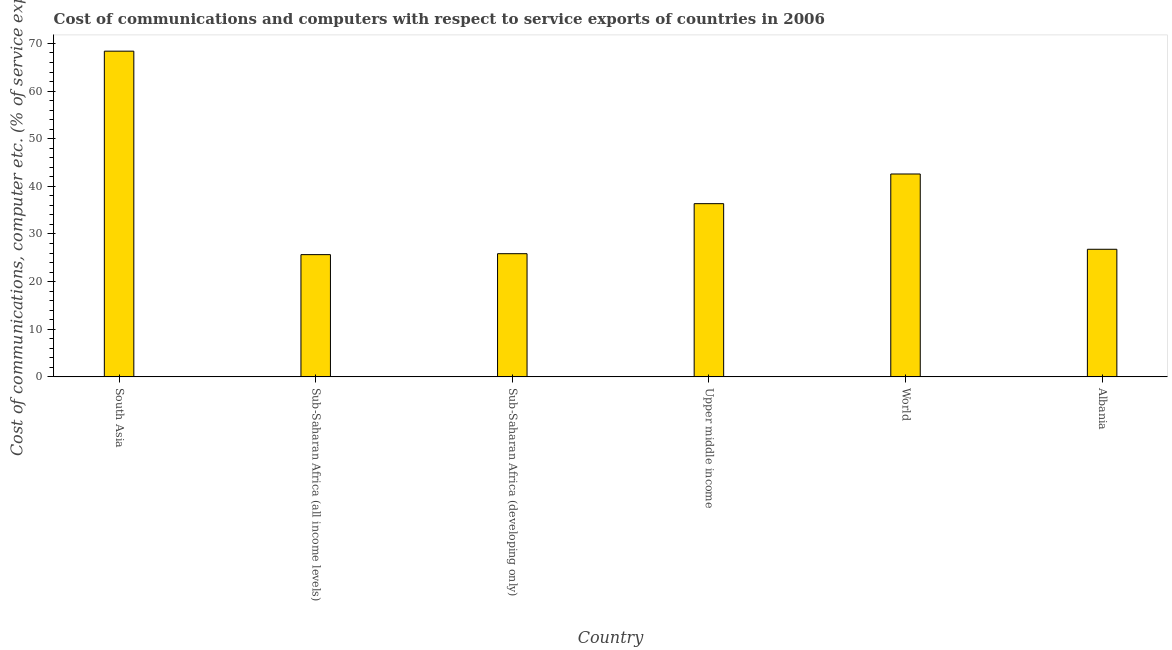Does the graph contain any zero values?
Ensure brevity in your answer.  No. What is the title of the graph?
Make the answer very short. Cost of communications and computers with respect to service exports of countries in 2006. What is the label or title of the X-axis?
Your answer should be very brief. Country. What is the label or title of the Y-axis?
Give a very brief answer. Cost of communications, computer etc. (% of service exports). What is the cost of communications and computer in Albania?
Keep it short and to the point. 26.79. Across all countries, what is the maximum cost of communications and computer?
Offer a very short reply. 68.39. Across all countries, what is the minimum cost of communications and computer?
Offer a terse response. 25.66. In which country was the cost of communications and computer minimum?
Your response must be concise. Sub-Saharan Africa (all income levels). What is the sum of the cost of communications and computer?
Offer a very short reply. 225.66. What is the difference between the cost of communications and computer in Albania and Sub-Saharan Africa (developing only)?
Give a very brief answer. 0.93. What is the average cost of communications and computer per country?
Provide a short and direct response. 37.61. What is the median cost of communications and computer?
Provide a succinct answer. 31.58. What is the ratio of the cost of communications and computer in Sub-Saharan Africa (developing only) to that in Upper middle income?
Your answer should be compact. 0.71. Is the cost of communications and computer in South Asia less than that in World?
Ensure brevity in your answer.  No. What is the difference between the highest and the second highest cost of communications and computer?
Offer a terse response. 25.79. What is the difference between the highest and the lowest cost of communications and computer?
Offer a very short reply. 42.72. How many bars are there?
Provide a succinct answer. 6. Are all the bars in the graph horizontal?
Provide a succinct answer. No. Are the values on the major ticks of Y-axis written in scientific E-notation?
Your answer should be very brief. No. What is the Cost of communications, computer etc. (% of service exports) in South Asia?
Make the answer very short. 68.39. What is the Cost of communications, computer etc. (% of service exports) in Sub-Saharan Africa (all income levels)?
Make the answer very short. 25.66. What is the Cost of communications, computer etc. (% of service exports) in Sub-Saharan Africa (developing only)?
Provide a short and direct response. 25.86. What is the Cost of communications, computer etc. (% of service exports) of Upper middle income?
Provide a succinct answer. 36.37. What is the Cost of communications, computer etc. (% of service exports) in World?
Ensure brevity in your answer.  42.59. What is the Cost of communications, computer etc. (% of service exports) of Albania?
Keep it short and to the point. 26.79. What is the difference between the Cost of communications, computer etc. (% of service exports) in South Asia and Sub-Saharan Africa (all income levels)?
Your answer should be very brief. 42.72. What is the difference between the Cost of communications, computer etc. (% of service exports) in South Asia and Sub-Saharan Africa (developing only)?
Keep it short and to the point. 42.52. What is the difference between the Cost of communications, computer etc. (% of service exports) in South Asia and Upper middle income?
Your answer should be compact. 32.02. What is the difference between the Cost of communications, computer etc. (% of service exports) in South Asia and World?
Offer a terse response. 25.79. What is the difference between the Cost of communications, computer etc. (% of service exports) in South Asia and Albania?
Your answer should be very brief. 41.59. What is the difference between the Cost of communications, computer etc. (% of service exports) in Sub-Saharan Africa (all income levels) and Sub-Saharan Africa (developing only)?
Provide a succinct answer. -0.2. What is the difference between the Cost of communications, computer etc. (% of service exports) in Sub-Saharan Africa (all income levels) and Upper middle income?
Offer a terse response. -10.7. What is the difference between the Cost of communications, computer etc. (% of service exports) in Sub-Saharan Africa (all income levels) and World?
Your answer should be compact. -16.93. What is the difference between the Cost of communications, computer etc. (% of service exports) in Sub-Saharan Africa (all income levels) and Albania?
Provide a succinct answer. -1.13. What is the difference between the Cost of communications, computer etc. (% of service exports) in Sub-Saharan Africa (developing only) and Upper middle income?
Offer a very short reply. -10.5. What is the difference between the Cost of communications, computer etc. (% of service exports) in Sub-Saharan Africa (developing only) and World?
Your answer should be very brief. -16.73. What is the difference between the Cost of communications, computer etc. (% of service exports) in Sub-Saharan Africa (developing only) and Albania?
Give a very brief answer. -0.93. What is the difference between the Cost of communications, computer etc. (% of service exports) in Upper middle income and World?
Provide a short and direct response. -6.23. What is the difference between the Cost of communications, computer etc. (% of service exports) in Upper middle income and Albania?
Provide a short and direct response. 9.57. What is the difference between the Cost of communications, computer etc. (% of service exports) in World and Albania?
Provide a short and direct response. 15.8. What is the ratio of the Cost of communications, computer etc. (% of service exports) in South Asia to that in Sub-Saharan Africa (all income levels)?
Make the answer very short. 2.67. What is the ratio of the Cost of communications, computer etc. (% of service exports) in South Asia to that in Sub-Saharan Africa (developing only)?
Offer a terse response. 2.64. What is the ratio of the Cost of communications, computer etc. (% of service exports) in South Asia to that in Upper middle income?
Offer a very short reply. 1.88. What is the ratio of the Cost of communications, computer etc. (% of service exports) in South Asia to that in World?
Your answer should be compact. 1.6. What is the ratio of the Cost of communications, computer etc. (% of service exports) in South Asia to that in Albania?
Provide a succinct answer. 2.55. What is the ratio of the Cost of communications, computer etc. (% of service exports) in Sub-Saharan Africa (all income levels) to that in Upper middle income?
Offer a terse response. 0.71. What is the ratio of the Cost of communications, computer etc. (% of service exports) in Sub-Saharan Africa (all income levels) to that in World?
Keep it short and to the point. 0.6. What is the ratio of the Cost of communications, computer etc. (% of service exports) in Sub-Saharan Africa (all income levels) to that in Albania?
Offer a very short reply. 0.96. What is the ratio of the Cost of communications, computer etc. (% of service exports) in Sub-Saharan Africa (developing only) to that in Upper middle income?
Offer a terse response. 0.71. What is the ratio of the Cost of communications, computer etc. (% of service exports) in Sub-Saharan Africa (developing only) to that in World?
Provide a succinct answer. 0.61. What is the ratio of the Cost of communications, computer etc. (% of service exports) in Sub-Saharan Africa (developing only) to that in Albania?
Offer a very short reply. 0.96. What is the ratio of the Cost of communications, computer etc. (% of service exports) in Upper middle income to that in World?
Ensure brevity in your answer.  0.85. What is the ratio of the Cost of communications, computer etc. (% of service exports) in Upper middle income to that in Albania?
Your answer should be compact. 1.36. What is the ratio of the Cost of communications, computer etc. (% of service exports) in World to that in Albania?
Offer a terse response. 1.59. 